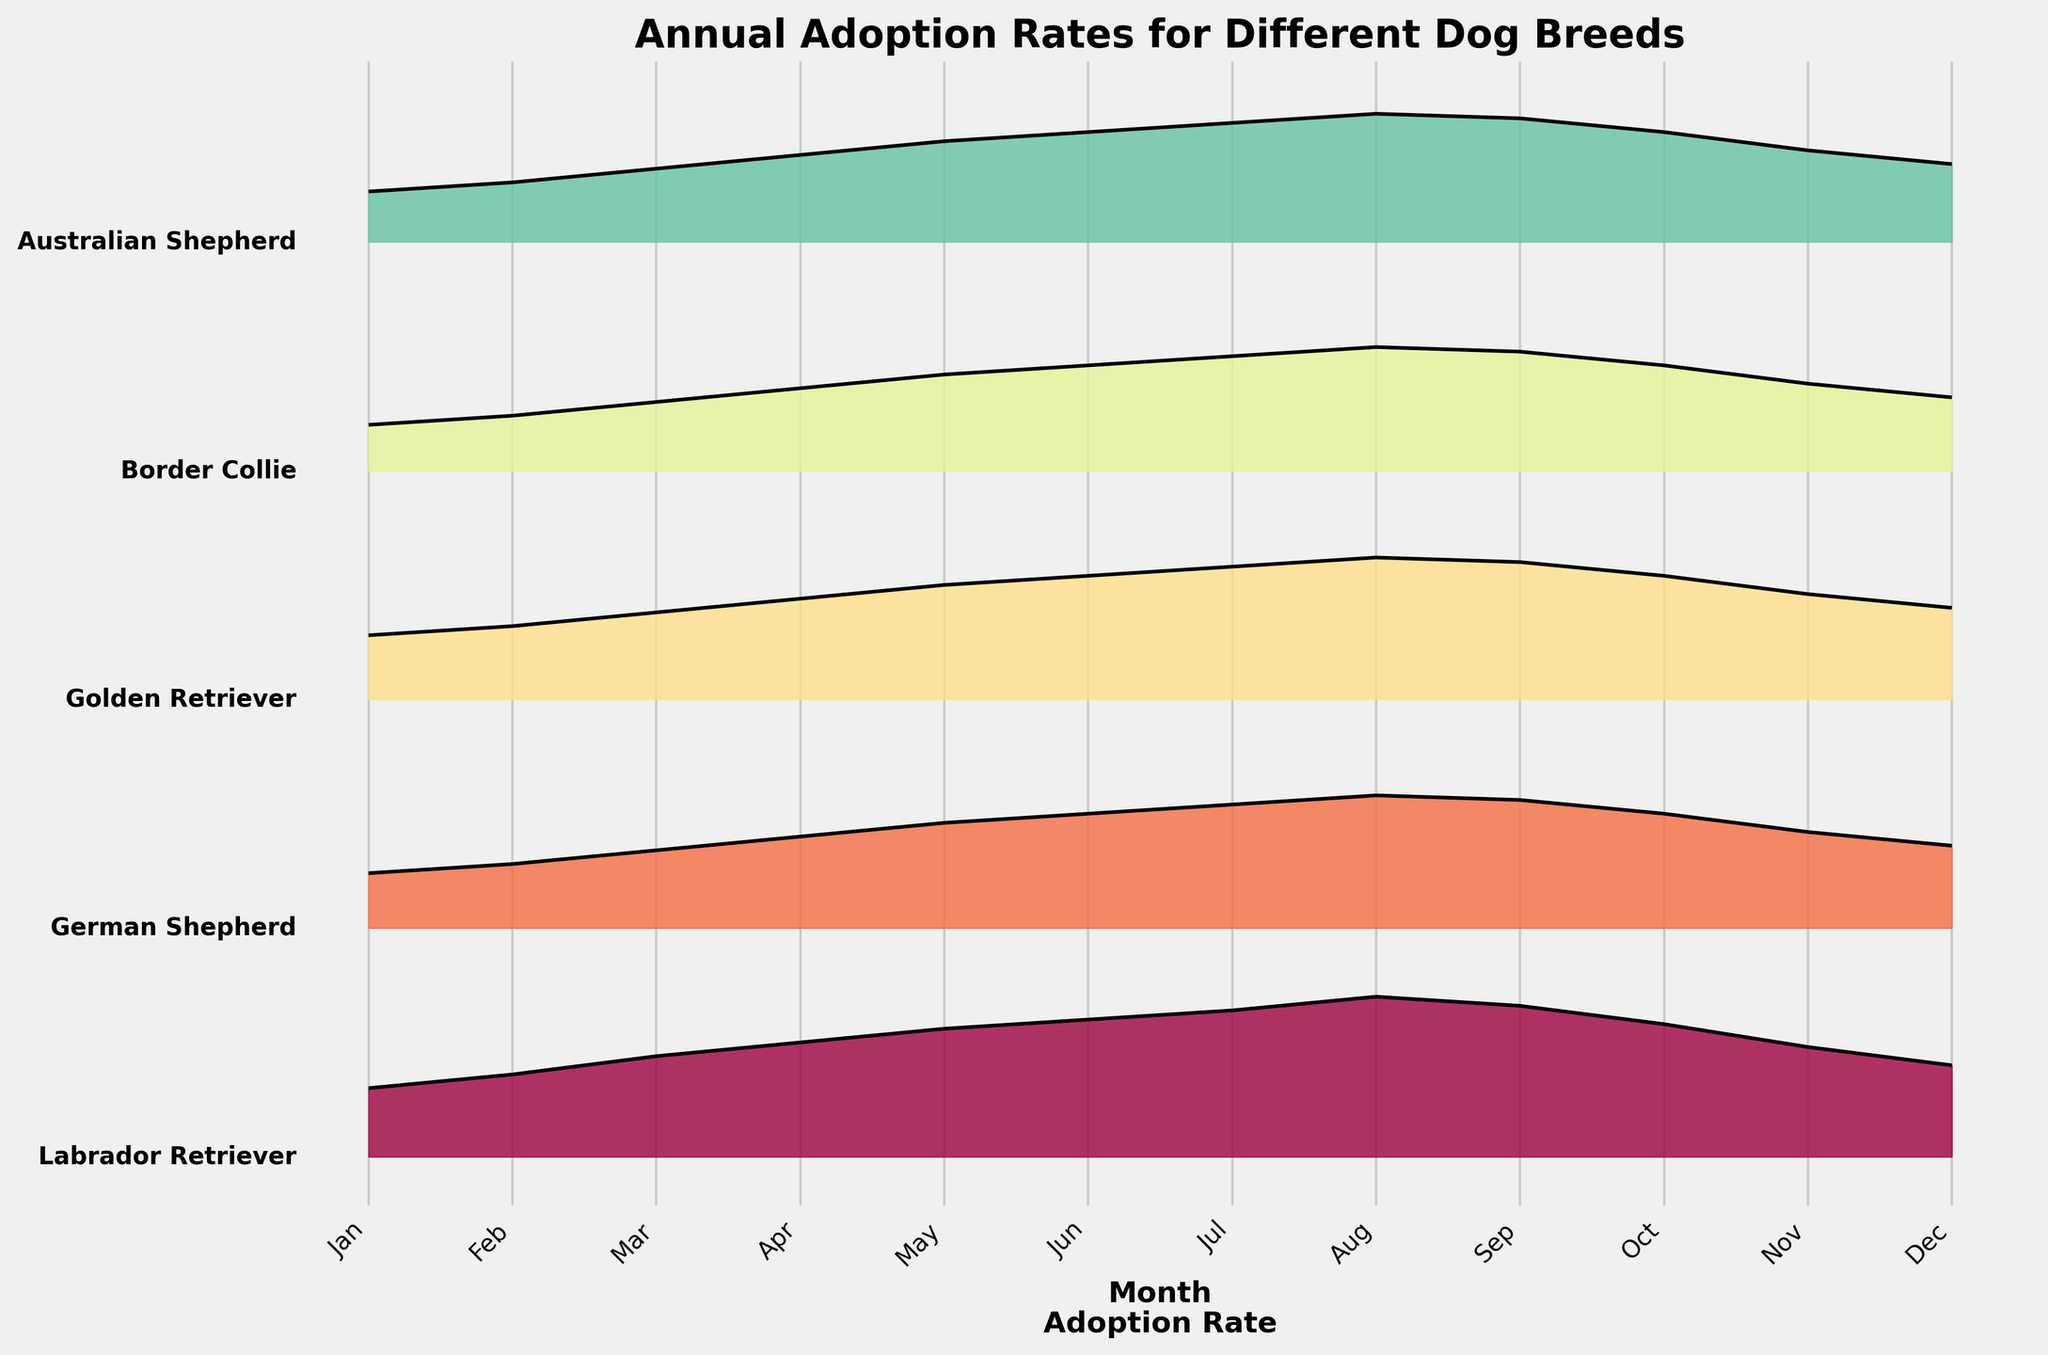What's the title of the plot? The title is placed at the top of the plot and is labeled clearly for easy identification. It summarizes the main subject of the plot, which helps in understanding what the plot aims to convey.
Answer: Annual Adoption Rates for Different Dog Breeds How many different dog breeds are represented in the plot? By examining the plot, we can see that each ridgeline corresponds to a different dog breed. We can count the number of distinct ridgelines from top to bottom.
Answer: 5 Which month shows the highest adoption rate for Labrador Retrievers? For this, we need to examine the ridgeline for Labrador Retrievers and find the peak of the curve, which represents the highest point. This peak occurs over the month of August.
Answer: August In which month do German Shepherds have the lowest adoption rate? To find this, we look at the ridgeline for German Shepherds and identify the minimum point of the curve. This is where the adoption rate is the lowest, which occurs in January.
Answer: January Compare the adoption rates of Golden Retrievers and Australian Shepherds in July. Which breed has a higher adoption rate? We need to find the points for both breeds in the month of July and compare their heights. The plot shows that the ridge height for Golden Retrievers in July is higher than that for Australian Shepherds.
Answer: Golden Retrievers What's the general trend of adoption rates for Border Collies throughout the year? To determine the trend, observe the general shape of the ridgeline for Border Collies. It starts low in January, gradually increases until August, and then decreases towards December.
Answer: Increasing then decreasing Which breed has the highest average adoption rate throughout the year? We must visually estimate the overall height of each ridgeline throughout the year. Labrador Retrievers have the highest average adoption rates, as their ridgeline is consistently higher than the others.
Answer: Labrador Retrievers How does the adoption rate of Australian Shepherds in June compare to that of Border Collies in the same month? Examine the ridge heights of both breeds in June. Australian Shepherds' ridge is higher than that of Border Collies for this month, indicating a higher adoption rate.
Answer: Australian Shepherds Which breed has the most significant seasonal variation in adoption rates? Look for the breed whose ridgeline shows the most fluctuation (peaks and valleys). Labrador Retrievers exhibit significant variation, with a substantial peak in summer months and a decline towards winter.
Answer: Labrador Retrievers In terms of visual representation, what does each ridgeline correspond to? Each ridgeline in the plot represents the annual adoption rate distribution for one specific dog breed. The height of the ridgeline at each point reflects the adoption rate for that month.
Answer: Adoption rates for each breed 